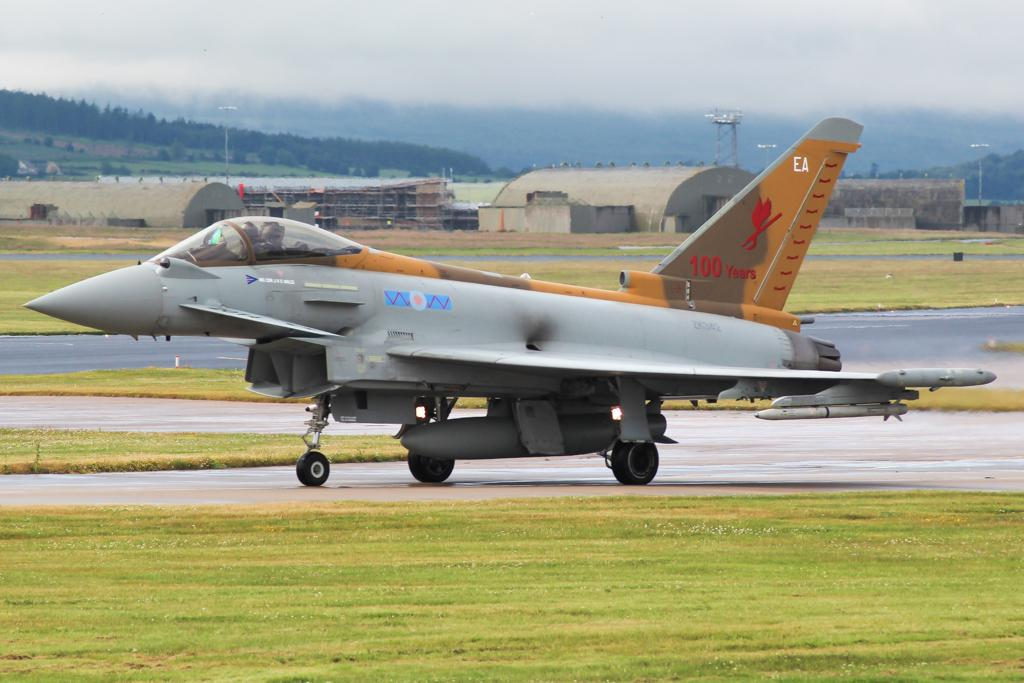What is the unusual object on the road in the image? There is an aeroplane on the road in the image. What type of vegetation can be seen in the image? There is grass visible in the image. What type of structures are present in the image? There are sheds, poles, and a tower in the image. What type of trees are visible in the image? There are trees in the image. What is visible in the background of the image? The sky is visible in the background of the image. What type of gate can be seen in the image? There is no gate present in the image. How does the aeroplane plan to rule the world in the image? The image does not depict the aeroplane planning to rule the world; it is simply an unusual object on the road. 